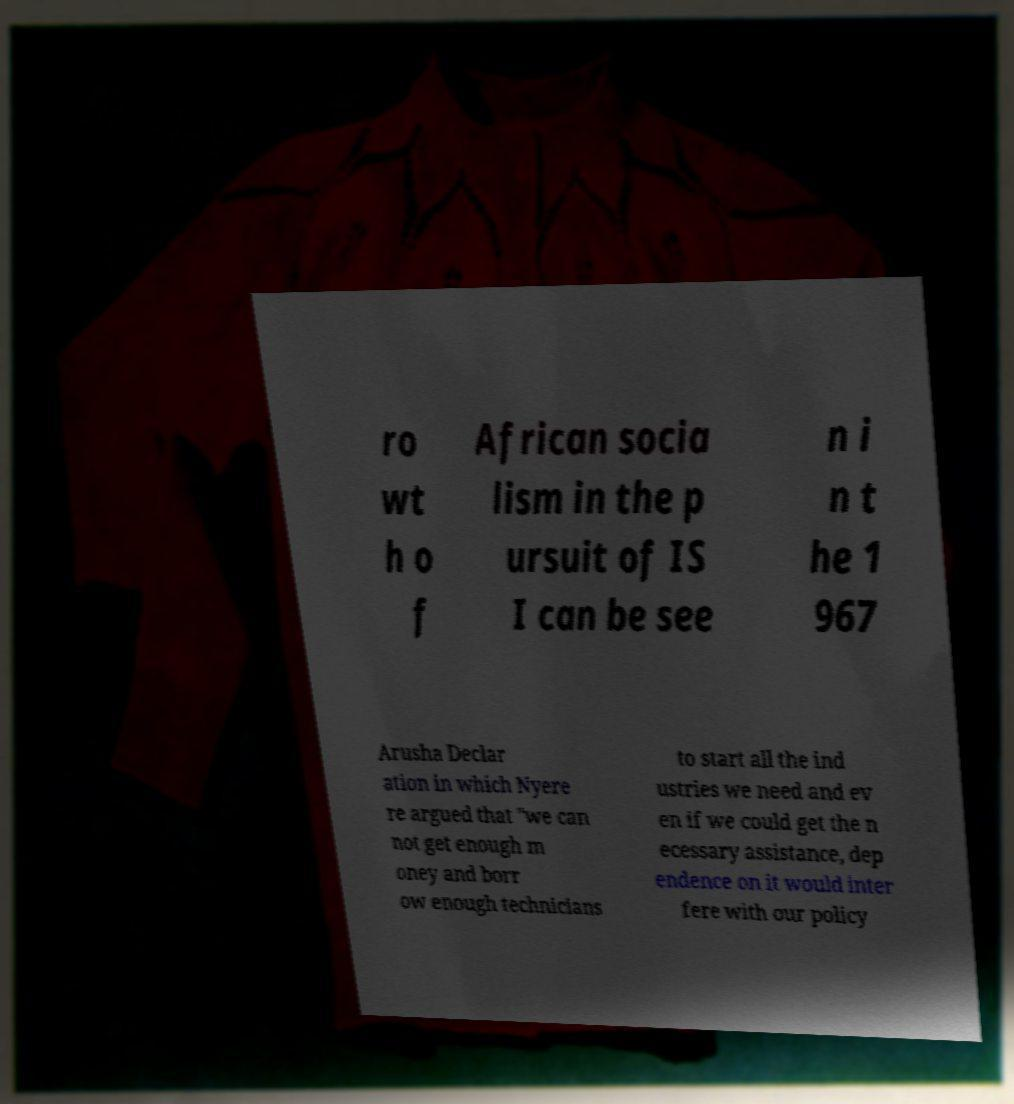Can you accurately transcribe the text from the provided image for me? ro wt h o f African socia lism in the p ursuit of IS I can be see n i n t he 1 967 Arusha Declar ation in which Nyere re argued that "we can not get enough m oney and borr ow enough technicians to start all the ind ustries we need and ev en if we could get the n ecessary assistance, dep endence on it would inter fere with our policy 